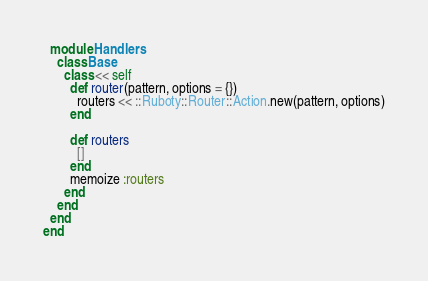Convert code to text. <code><loc_0><loc_0><loc_500><loc_500><_Ruby_>  module Handlers
    class Base
      class << self
        def router(pattern, options = {})
          routers << ::Ruboty::Router::Action.new(pattern, options)
        end

        def routers
          []
        end
        memoize :routers
      end
    end
  end
end
</code> 